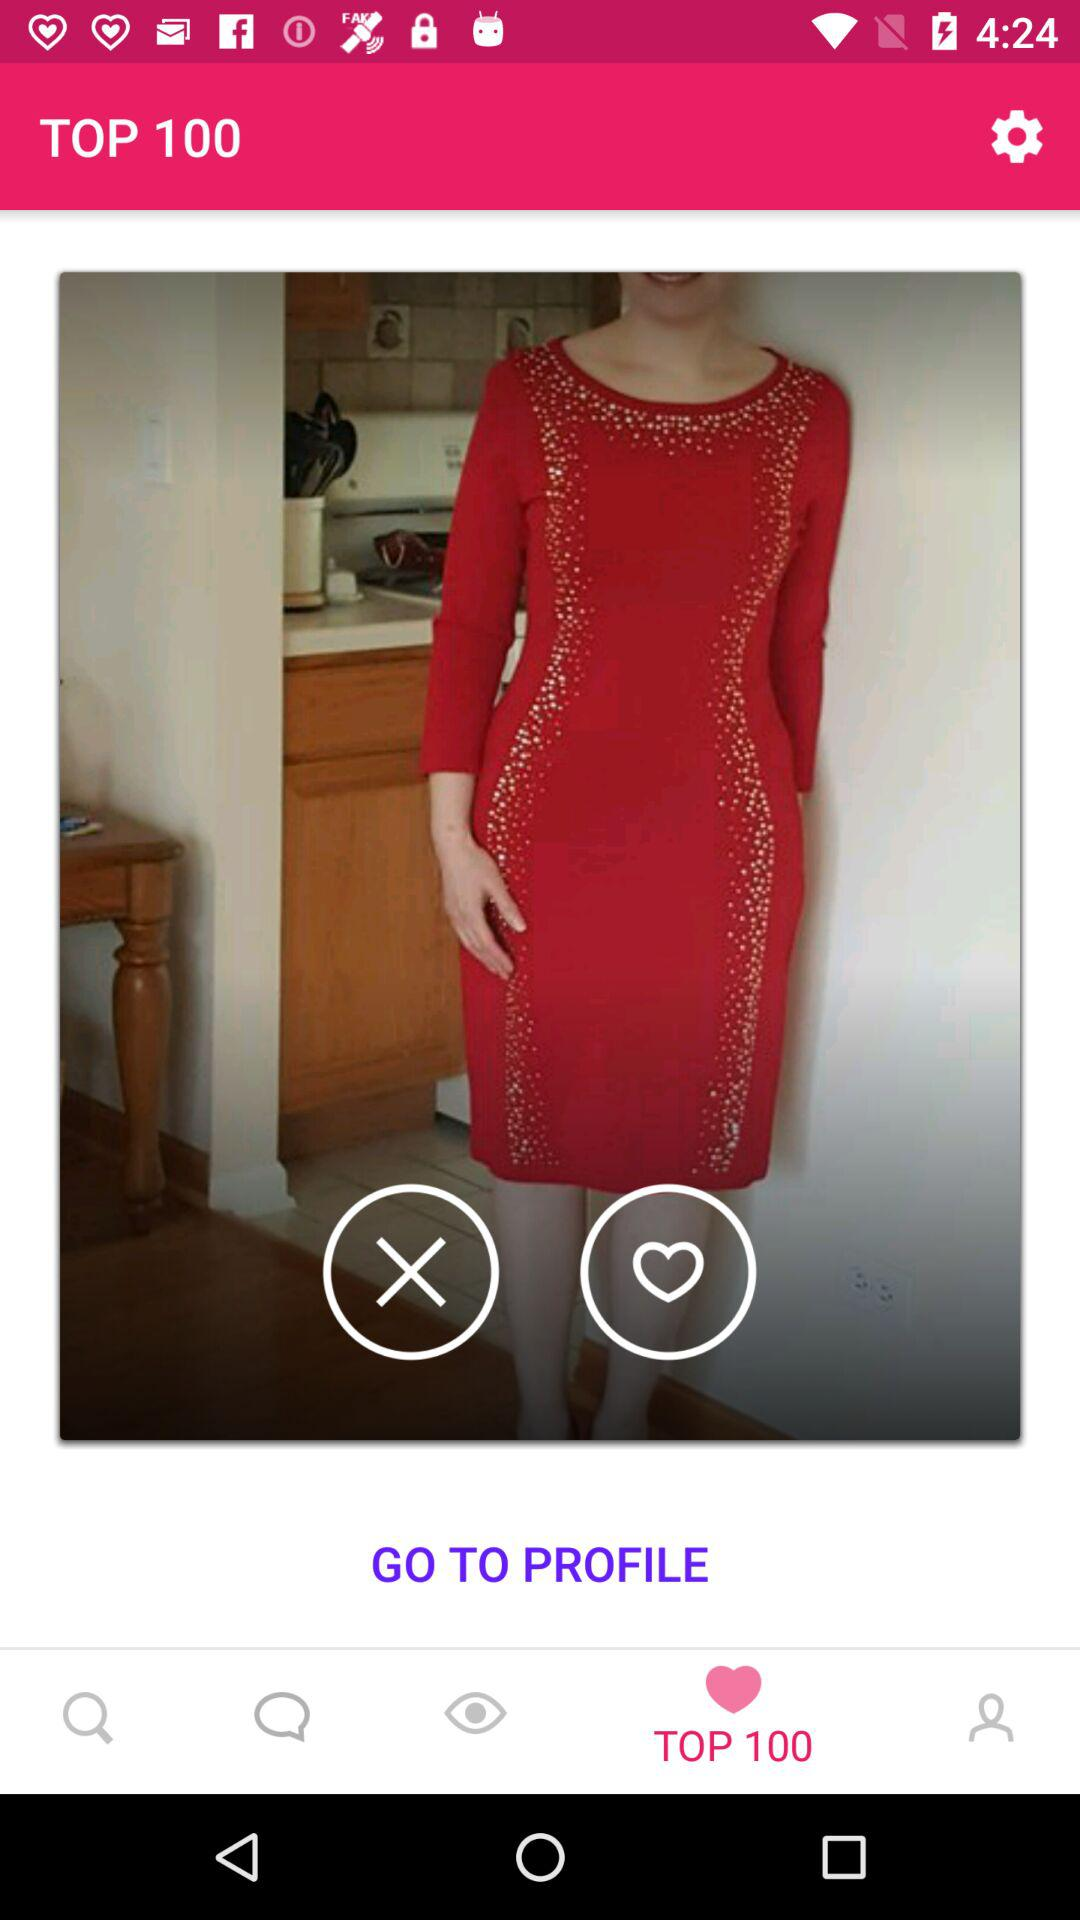How many views does the profile have?
When the provided information is insufficient, respond with <no answer>. <no answer> 